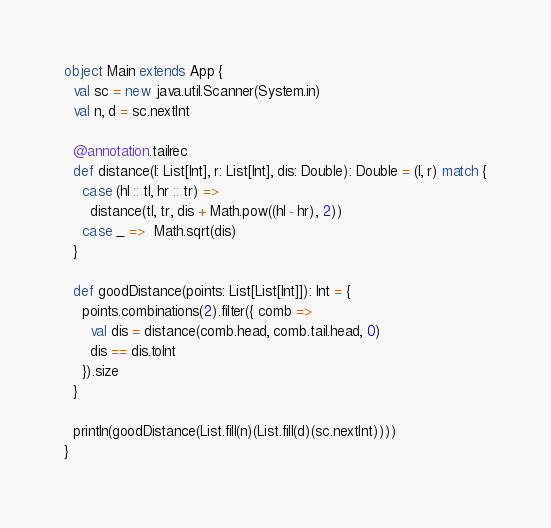Convert code to text. <code><loc_0><loc_0><loc_500><loc_500><_Scala_>object Main extends App {
  val sc = new java.util.Scanner(System.in)
  val n, d = sc.nextInt

  @annotation.tailrec
  def distance(l: List[Int], r: List[Int], dis: Double): Double = (l, r) match {
    case (hl :: tl, hr :: tr) =>
      distance(tl, tr, dis + Math.pow((hl - hr), 2))
    case _ =>  Math.sqrt(dis)
  }

  def goodDistance(points: List[List[Int]]): Int = {
    points.combinations(2).filter({ comb =>
      val dis = distance(comb.head, comb.tail.head, 0)
      dis == dis.toInt
    }).size
  }

  println(goodDistance(List.fill(n)(List.fill(d)(sc.nextInt))))
}</code> 